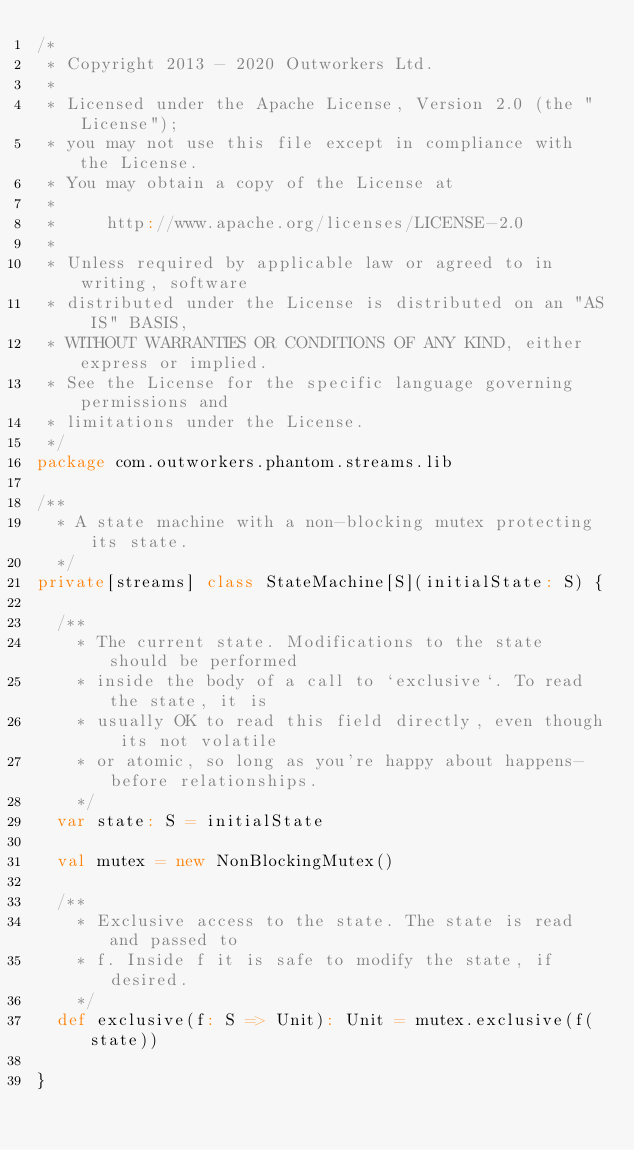Convert code to text. <code><loc_0><loc_0><loc_500><loc_500><_Scala_>/*
 * Copyright 2013 - 2020 Outworkers Ltd.
 *
 * Licensed under the Apache License, Version 2.0 (the "License");
 * you may not use this file except in compliance with the License.
 * You may obtain a copy of the License at
 *
 *     http://www.apache.org/licenses/LICENSE-2.0
 *
 * Unless required by applicable law or agreed to in writing, software
 * distributed under the License is distributed on an "AS IS" BASIS,
 * WITHOUT WARRANTIES OR CONDITIONS OF ANY KIND, either express or implied.
 * See the License for the specific language governing permissions and
 * limitations under the License.
 */
package com.outworkers.phantom.streams.lib

/**
  * A state machine with a non-blocking mutex protecting its state.
  */
private[streams] class StateMachine[S](initialState: S) {

  /**
    * The current state. Modifications to the state should be performed
    * inside the body of a call to `exclusive`. To read the state, it is
    * usually OK to read this field directly, even though its not volatile
    * or atomic, so long as you're happy about happens-before relationships.
    */
  var state: S = initialState

  val mutex = new NonBlockingMutex()

  /**
    * Exclusive access to the state. The state is read and passed to
    * f. Inside f it is safe to modify the state, if desired.
    */
  def exclusive(f: S => Unit): Unit = mutex.exclusive(f(state))

}
</code> 